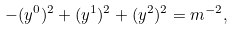Convert formula to latex. <formula><loc_0><loc_0><loc_500><loc_500>- ( y ^ { 0 } ) ^ { 2 } + ( y ^ { 1 } ) ^ { 2 } + ( y ^ { 2 } ) ^ { 2 } = m ^ { - 2 } ,</formula> 